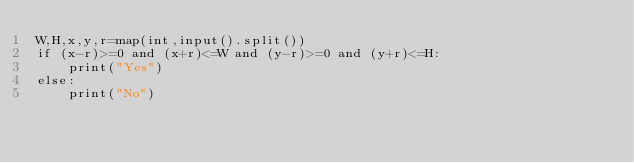<code> <loc_0><loc_0><loc_500><loc_500><_Python_>W,H,x,y,r=map(int,input().split())
if (x-r)>=0 and (x+r)<=W and (y-r)>=0 and (y+r)<=H:
    print("Yes")
else:
    print("No")
</code> 